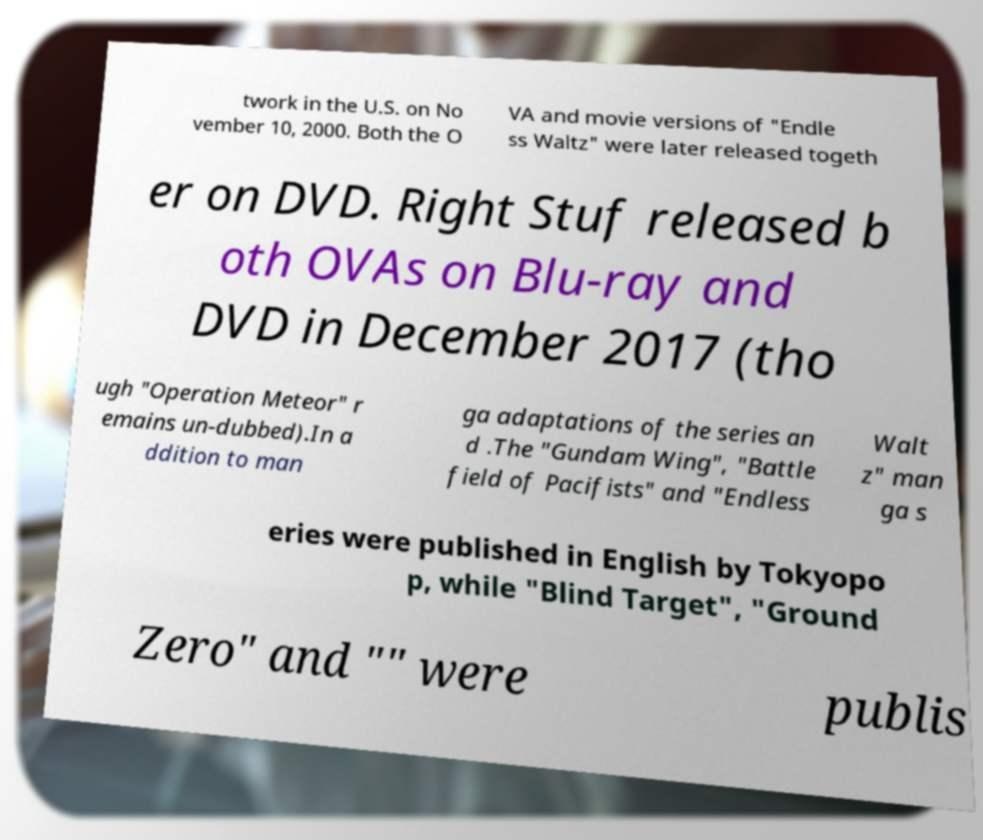What messages or text are displayed in this image? I need them in a readable, typed format. twork in the U.S. on No vember 10, 2000. Both the O VA and movie versions of "Endle ss Waltz" were later released togeth er on DVD. Right Stuf released b oth OVAs on Blu-ray and DVD in December 2017 (tho ugh "Operation Meteor" r emains un-dubbed).In a ddition to man ga adaptations of the series an d .The "Gundam Wing", "Battle field of Pacifists" and "Endless Walt z" man ga s eries were published in English by Tokyopo p, while "Blind Target", "Ground Zero" and "" were publis 